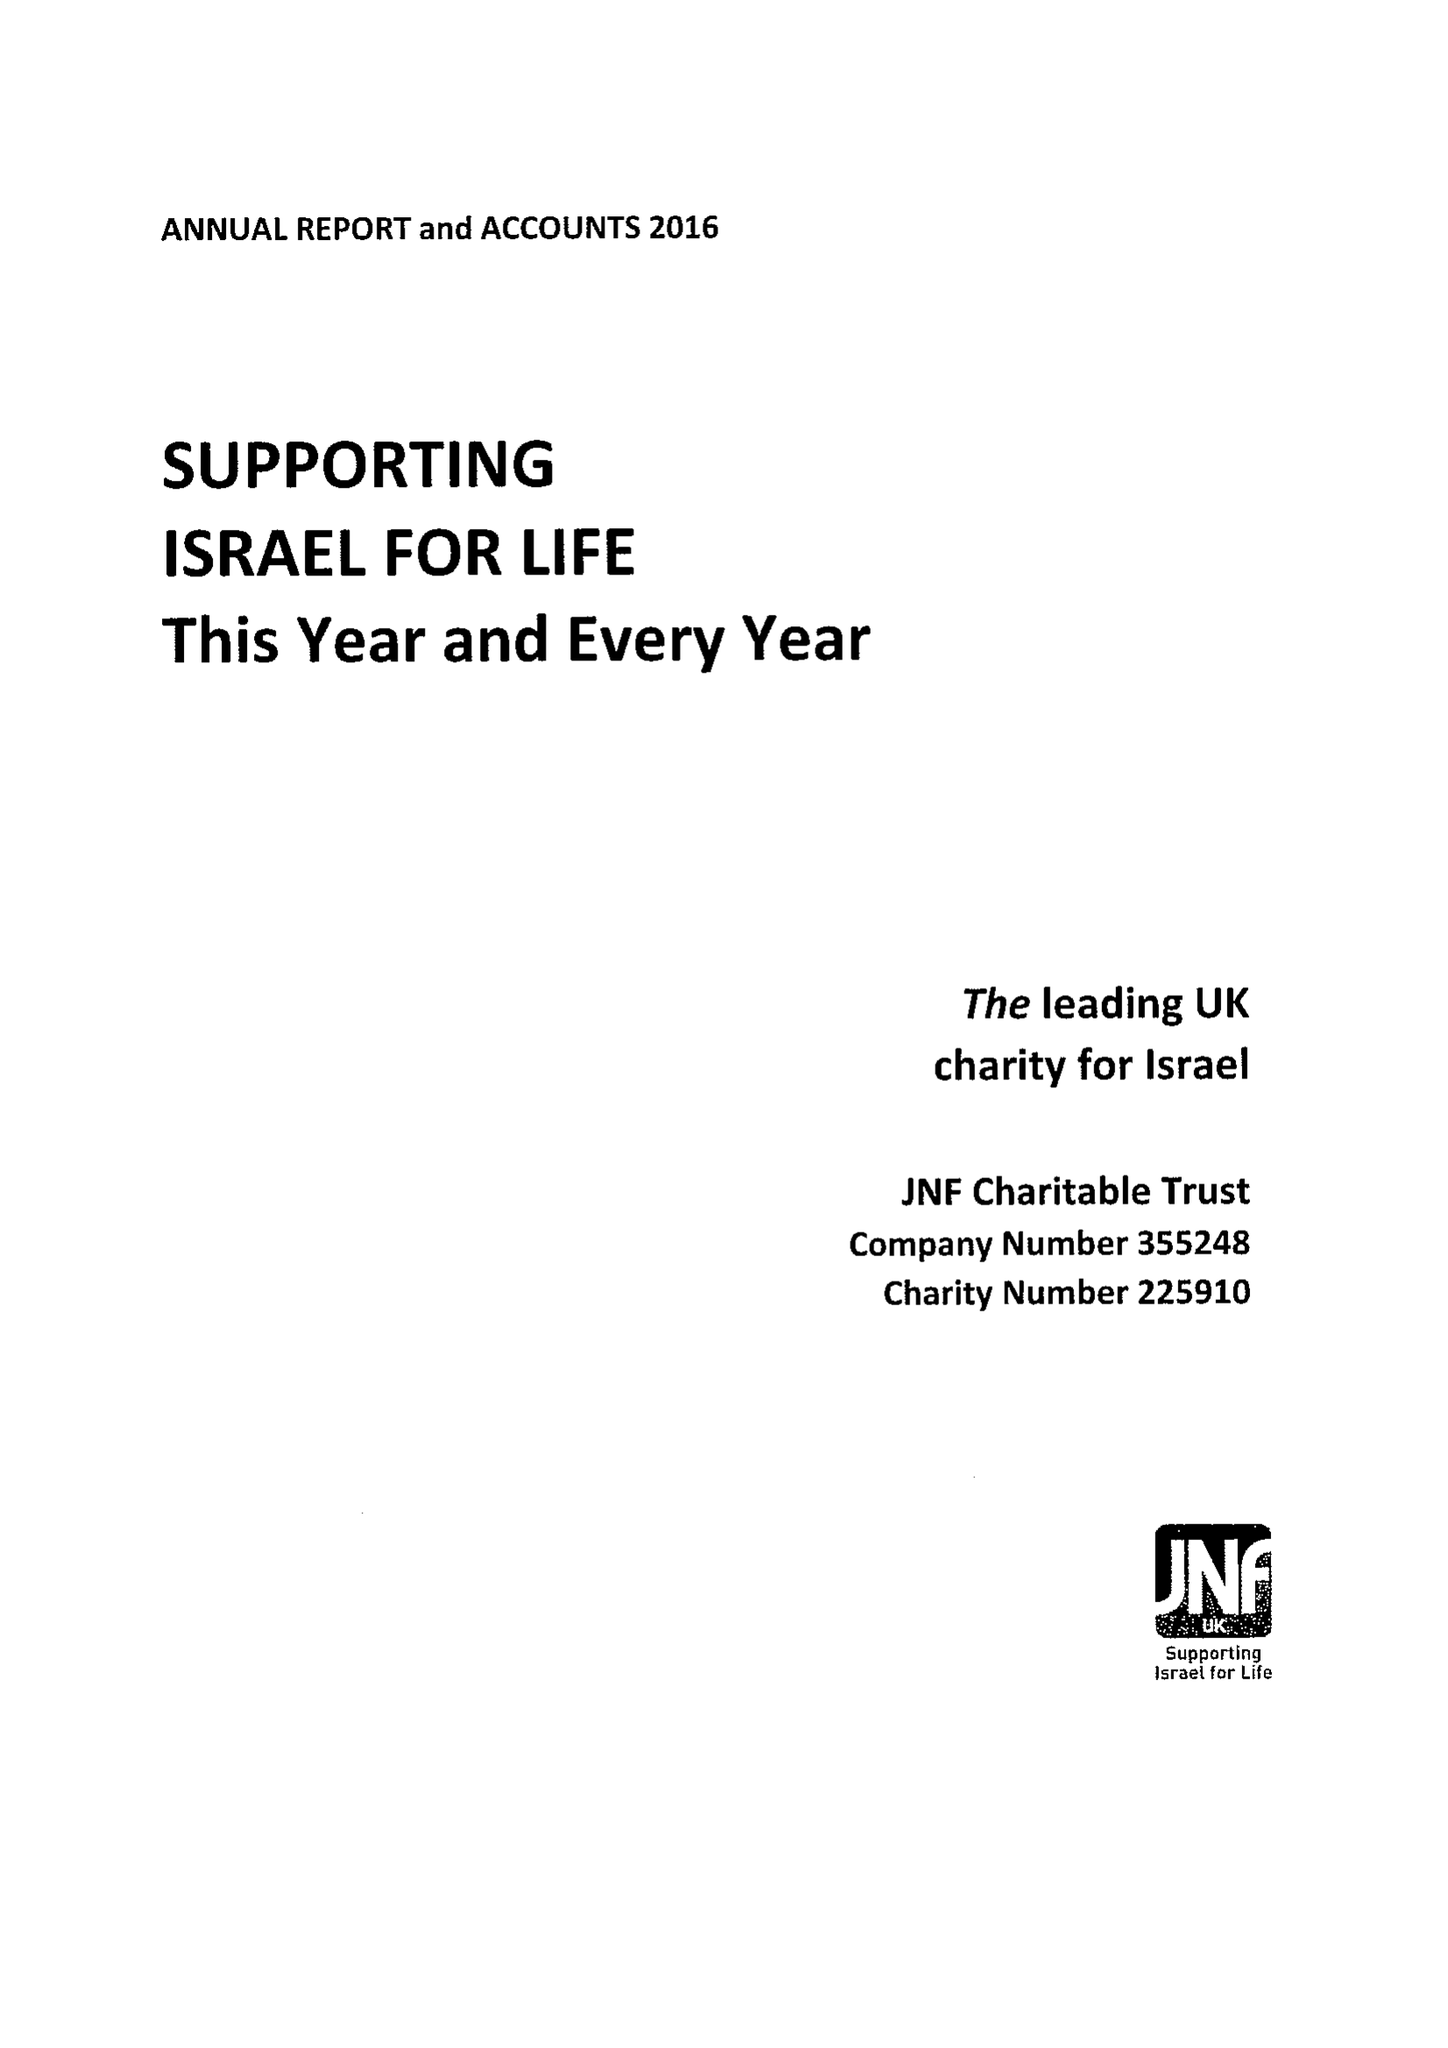What is the value for the charity_name?
Answer the question using a single word or phrase. Jnf Charitable Trust 